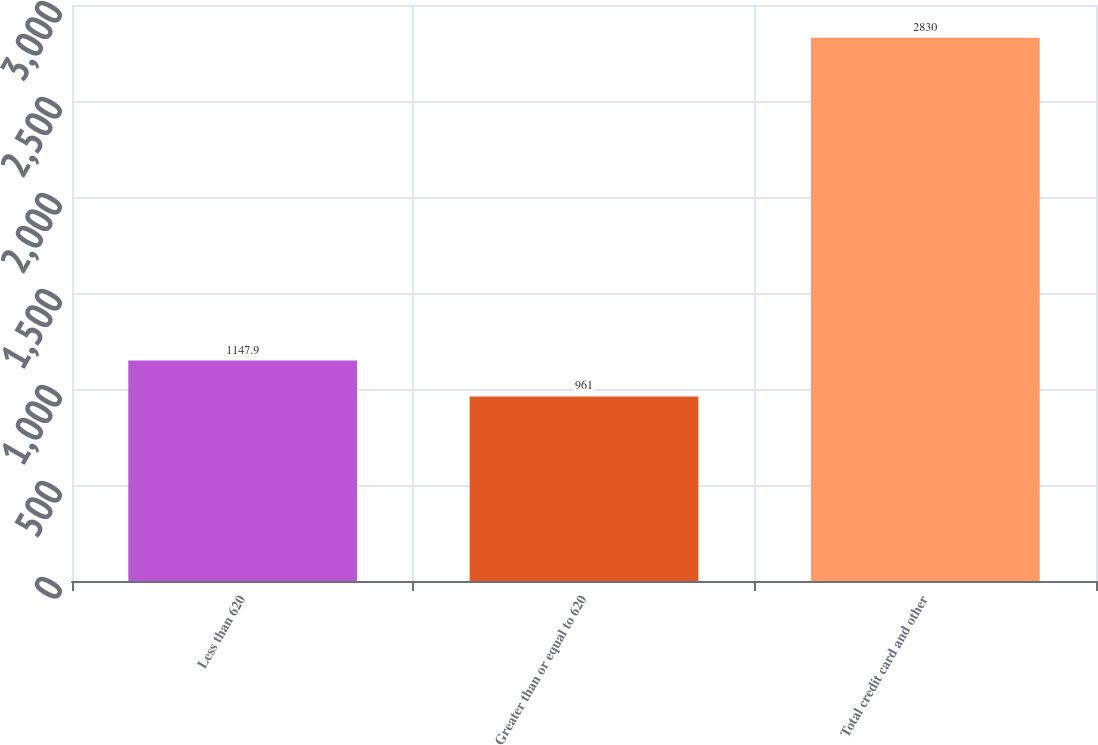Convert chart. <chart><loc_0><loc_0><loc_500><loc_500><bar_chart><fcel>Less than 620<fcel>Greater than or equal to 620<fcel>Total credit card and other<nl><fcel>1147.9<fcel>961<fcel>2830<nl></chart> 